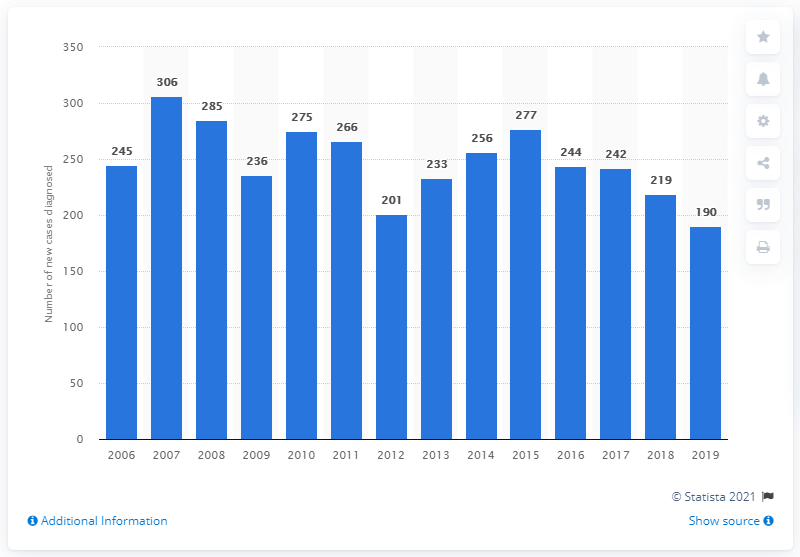Draw attention to some important aspects in this diagram. The highest number of new cases of HIV diagnosed in Denmark was in 2007, In 2018, a total of 190 new cases of HIV were diagnosed in Denmark. 